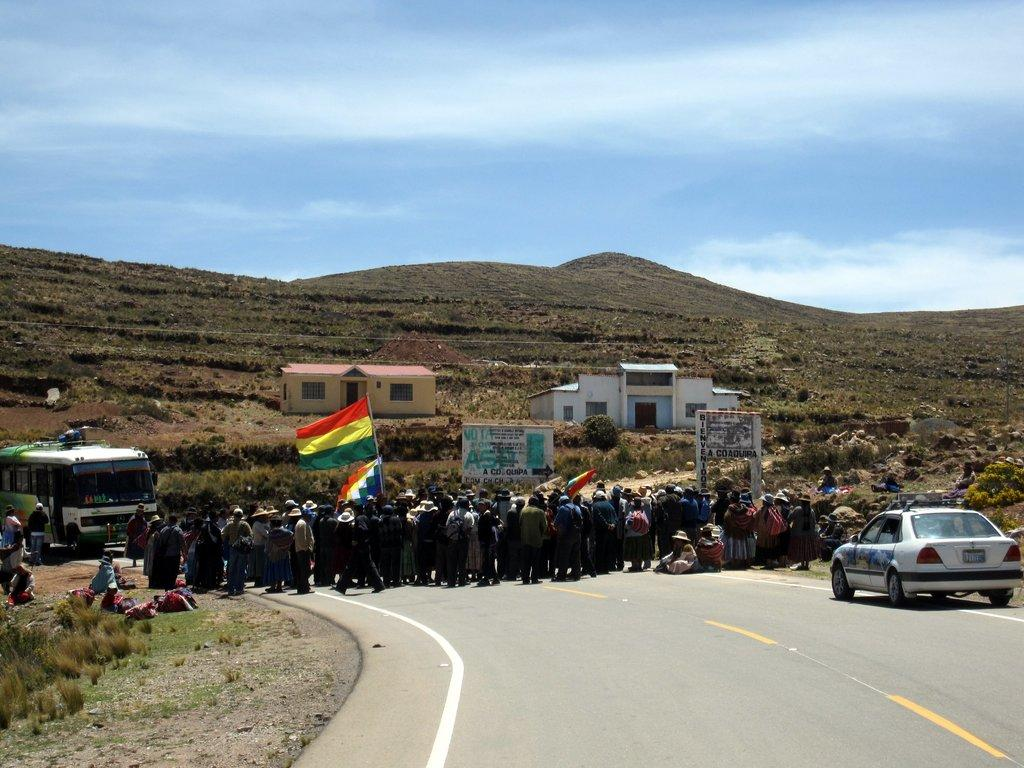What is located in the foreground of the image? There is a crowd, a car, and a bus in the foreground of the image. What type of vehicles can be seen in the foreground? A car and a bus can be seen in the foreground. What can be seen in the background of the image? There are houses, mountains, and the sky visible in the background. What is the time of day when the image was taken? The image was taken during the day. What type of pancake is being served at the event in the image? There is no event or pancake present in the image. How many grapes are visible on the vine in the image? There is no vine or grapes present in the image. 